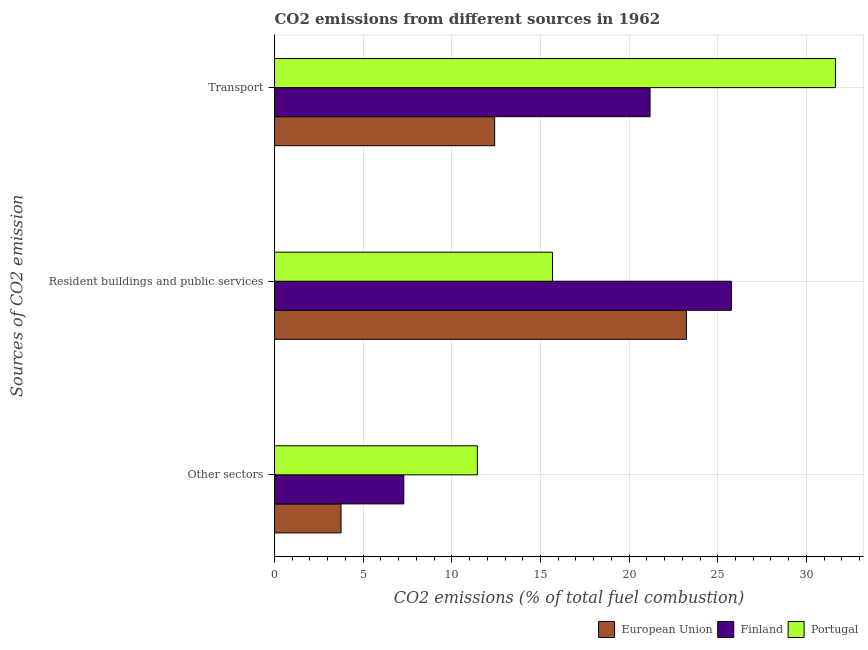Are the number of bars on each tick of the Y-axis equal?
Your response must be concise. Yes. How many bars are there on the 1st tick from the top?
Provide a short and direct response. 3. What is the label of the 3rd group of bars from the top?
Provide a short and direct response. Other sectors. What is the percentage of co2 emissions from other sectors in European Union?
Offer a terse response. 3.75. Across all countries, what is the maximum percentage of co2 emissions from resident buildings and public services?
Give a very brief answer. 25.77. Across all countries, what is the minimum percentage of co2 emissions from other sectors?
Your answer should be very brief. 3.75. In which country was the percentage of co2 emissions from transport maximum?
Your response must be concise. Portugal. In which country was the percentage of co2 emissions from other sectors minimum?
Give a very brief answer. European Union. What is the total percentage of co2 emissions from transport in the graph?
Provide a succinct answer. 65.24. What is the difference between the percentage of co2 emissions from other sectors in Portugal and that in Finland?
Your answer should be very brief. 4.15. What is the difference between the percentage of co2 emissions from resident buildings and public services in Portugal and the percentage of co2 emissions from transport in Finland?
Offer a terse response. -5.5. What is the average percentage of co2 emissions from other sectors per country?
Provide a short and direct response. 7.49. What is the difference between the percentage of co2 emissions from resident buildings and public services and percentage of co2 emissions from other sectors in Portugal?
Provide a short and direct response. 4.24. What is the ratio of the percentage of co2 emissions from transport in European Union to that in Portugal?
Your answer should be compact. 0.39. What is the difference between the highest and the second highest percentage of co2 emissions from transport?
Ensure brevity in your answer.  10.46. What is the difference between the highest and the lowest percentage of co2 emissions from transport?
Offer a terse response. 19.22. In how many countries, is the percentage of co2 emissions from resident buildings and public services greater than the average percentage of co2 emissions from resident buildings and public services taken over all countries?
Your response must be concise. 2. What does the 2nd bar from the bottom in Resident buildings and public services represents?
Ensure brevity in your answer.  Finland. How many bars are there?
Your answer should be very brief. 9. What is the difference between two consecutive major ticks on the X-axis?
Provide a succinct answer. 5. Are the values on the major ticks of X-axis written in scientific E-notation?
Offer a terse response. No. Does the graph contain grids?
Provide a short and direct response. Yes. How many legend labels are there?
Your answer should be compact. 3. How are the legend labels stacked?
Make the answer very short. Horizontal. What is the title of the graph?
Your answer should be compact. CO2 emissions from different sources in 1962. What is the label or title of the X-axis?
Your answer should be very brief. CO2 emissions (% of total fuel combustion). What is the label or title of the Y-axis?
Keep it short and to the point. Sources of CO2 emission. What is the CO2 emissions (% of total fuel combustion) in European Union in Other sectors?
Ensure brevity in your answer.  3.75. What is the CO2 emissions (% of total fuel combustion) of Finland in Other sectors?
Give a very brief answer. 7.29. What is the CO2 emissions (% of total fuel combustion) of Portugal in Other sectors?
Ensure brevity in your answer.  11.44. What is the CO2 emissions (% of total fuel combustion) in European Union in Resident buildings and public services?
Your response must be concise. 23.23. What is the CO2 emissions (% of total fuel combustion) in Finland in Resident buildings and public services?
Offer a terse response. 25.77. What is the CO2 emissions (% of total fuel combustion) in Portugal in Resident buildings and public services?
Provide a short and direct response. 15.68. What is the CO2 emissions (% of total fuel combustion) in European Union in Transport?
Keep it short and to the point. 12.42. What is the CO2 emissions (% of total fuel combustion) in Finland in Transport?
Your answer should be very brief. 21.18. What is the CO2 emissions (% of total fuel combustion) in Portugal in Transport?
Ensure brevity in your answer.  31.64. Across all Sources of CO2 emission, what is the maximum CO2 emissions (% of total fuel combustion) in European Union?
Give a very brief answer. 23.23. Across all Sources of CO2 emission, what is the maximum CO2 emissions (% of total fuel combustion) of Finland?
Provide a short and direct response. 25.77. Across all Sources of CO2 emission, what is the maximum CO2 emissions (% of total fuel combustion) in Portugal?
Offer a very short reply. 31.64. Across all Sources of CO2 emission, what is the minimum CO2 emissions (% of total fuel combustion) in European Union?
Provide a succinct answer. 3.75. Across all Sources of CO2 emission, what is the minimum CO2 emissions (% of total fuel combustion) in Finland?
Make the answer very short. 7.29. Across all Sources of CO2 emission, what is the minimum CO2 emissions (% of total fuel combustion) in Portugal?
Provide a succinct answer. 11.44. What is the total CO2 emissions (% of total fuel combustion) of European Union in the graph?
Keep it short and to the point. 39.4. What is the total CO2 emissions (% of total fuel combustion) in Finland in the graph?
Give a very brief answer. 54.24. What is the total CO2 emissions (% of total fuel combustion) in Portugal in the graph?
Provide a short and direct response. 58.76. What is the difference between the CO2 emissions (% of total fuel combustion) in European Union in Other sectors and that in Resident buildings and public services?
Make the answer very short. -19.48. What is the difference between the CO2 emissions (% of total fuel combustion) of Finland in Other sectors and that in Resident buildings and public services?
Your response must be concise. -18.48. What is the difference between the CO2 emissions (% of total fuel combustion) of Portugal in Other sectors and that in Resident buildings and public services?
Keep it short and to the point. -4.24. What is the difference between the CO2 emissions (% of total fuel combustion) of European Union in Other sectors and that in Transport?
Offer a terse response. -8.67. What is the difference between the CO2 emissions (% of total fuel combustion) of Finland in Other sectors and that in Transport?
Give a very brief answer. -13.89. What is the difference between the CO2 emissions (% of total fuel combustion) in Portugal in Other sectors and that in Transport?
Ensure brevity in your answer.  -20.2. What is the difference between the CO2 emissions (% of total fuel combustion) of European Union in Resident buildings and public services and that in Transport?
Your response must be concise. 10.81. What is the difference between the CO2 emissions (% of total fuel combustion) of Finland in Resident buildings and public services and that in Transport?
Your answer should be very brief. 4.59. What is the difference between the CO2 emissions (% of total fuel combustion) of Portugal in Resident buildings and public services and that in Transport?
Offer a terse response. -15.96. What is the difference between the CO2 emissions (% of total fuel combustion) in European Union in Other sectors and the CO2 emissions (% of total fuel combustion) in Finland in Resident buildings and public services?
Your answer should be very brief. -22.02. What is the difference between the CO2 emissions (% of total fuel combustion) in European Union in Other sectors and the CO2 emissions (% of total fuel combustion) in Portugal in Resident buildings and public services?
Offer a terse response. -11.93. What is the difference between the CO2 emissions (% of total fuel combustion) in Finland in Other sectors and the CO2 emissions (% of total fuel combustion) in Portugal in Resident buildings and public services?
Ensure brevity in your answer.  -8.39. What is the difference between the CO2 emissions (% of total fuel combustion) of European Union in Other sectors and the CO2 emissions (% of total fuel combustion) of Finland in Transport?
Provide a short and direct response. -17.43. What is the difference between the CO2 emissions (% of total fuel combustion) in European Union in Other sectors and the CO2 emissions (% of total fuel combustion) in Portugal in Transport?
Give a very brief answer. -27.89. What is the difference between the CO2 emissions (% of total fuel combustion) of Finland in Other sectors and the CO2 emissions (% of total fuel combustion) of Portugal in Transport?
Ensure brevity in your answer.  -24.35. What is the difference between the CO2 emissions (% of total fuel combustion) of European Union in Resident buildings and public services and the CO2 emissions (% of total fuel combustion) of Finland in Transport?
Provide a succinct answer. 2.05. What is the difference between the CO2 emissions (% of total fuel combustion) of European Union in Resident buildings and public services and the CO2 emissions (% of total fuel combustion) of Portugal in Transport?
Give a very brief answer. -8.41. What is the difference between the CO2 emissions (% of total fuel combustion) in Finland in Resident buildings and public services and the CO2 emissions (% of total fuel combustion) in Portugal in Transport?
Offer a very short reply. -5.87. What is the average CO2 emissions (% of total fuel combustion) in European Union per Sources of CO2 emission?
Give a very brief answer. 13.13. What is the average CO2 emissions (% of total fuel combustion) in Finland per Sources of CO2 emission?
Keep it short and to the point. 18.08. What is the average CO2 emissions (% of total fuel combustion) of Portugal per Sources of CO2 emission?
Provide a succinct answer. 19.59. What is the difference between the CO2 emissions (% of total fuel combustion) of European Union and CO2 emissions (% of total fuel combustion) of Finland in Other sectors?
Provide a succinct answer. -3.54. What is the difference between the CO2 emissions (% of total fuel combustion) of European Union and CO2 emissions (% of total fuel combustion) of Portugal in Other sectors?
Your answer should be compact. -7.69. What is the difference between the CO2 emissions (% of total fuel combustion) in Finland and CO2 emissions (% of total fuel combustion) in Portugal in Other sectors?
Your response must be concise. -4.15. What is the difference between the CO2 emissions (% of total fuel combustion) of European Union and CO2 emissions (% of total fuel combustion) of Finland in Resident buildings and public services?
Offer a very short reply. -2.54. What is the difference between the CO2 emissions (% of total fuel combustion) in European Union and CO2 emissions (% of total fuel combustion) in Portugal in Resident buildings and public services?
Offer a terse response. 7.55. What is the difference between the CO2 emissions (% of total fuel combustion) in Finland and CO2 emissions (% of total fuel combustion) in Portugal in Resident buildings and public services?
Offer a terse response. 10.09. What is the difference between the CO2 emissions (% of total fuel combustion) of European Union and CO2 emissions (% of total fuel combustion) of Finland in Transport?
Provide a short and direct response. -8.76. What is the difference between the CO2 emissions (% of total fuel combustion) of European Union and CO2 emissions (% of total fuel combustion) of Portugal in Transport?
Your answer should be compact. -19.22. What is the difference between the CO2 emissions (% of total fuel combustion) in Finland and CO2 emissions (% of total fuel combustion) in Portugal in Transport?
Provide a short and direct response. -10.46. What is the ratio of the CO2 emissions (% of total fuel combustion) of European Union in Other sectors to that in Resident buildings and public services?
Offer a very short reply. 0.16. What is the ratio of the CO2 emissions (% of total fuel combustion) in Finland in Other sectors to that in Resident buildings and public services?
Make the answer very short. 0.28. What is the ratio of the CO2 emissions (% of total fuel combustion) of Portugal in Other sectors to that in Resident buildings and public services?
Offer a terse response. 0.73. What is the ratio of the CO2 emissions (% of total fuel combustion) of European Union in Other sectors to that in Transport?
Your answer should be very brief. 0.3. What is the ratio of the CO2 emissions (% of total fuel combustion) of Finland in Other sectors to that in Transport?
Provide a short and direct response. 0.34. What is the ratio of the CO2 emissions (% of total fuel combustion) of Portugal in Other sectors to that in Transport?
Your answer should be compact. 0.36. What is the ratio of the CO2 emissions (% of total fuel combustion) of European Union in Resident buildings and public services to that in Transport?
Keep it short and to the point. 1.87. What is the ratio of the CO2 emissions (% of total fuel combustion) in Finland in Resident buildings and public services to that in Transport?
Keep it short and to the point. 1.22. What is the ratio of the CO2 emissions (% of total fuel combustion) of Portugal in Resident buildings and public services to that in Transport?
Your response must be concise. 0.5. What is the difference between the highest and the second highest CO2 emissions (% of total fuel combustion) in European Union?
Give a very brief answer. 10.81. What is the difference between the highest and the second highest CO2 emissions (% of total fuel combustion) of Finland?
Your response must be concise. 4.59. What is the difference between the highest and the second highest CO2 emissions (% of total fuel combustion) of Portugal?
Offer a very short reply. 15.96. What is the difference between the highest and the lowest CO2 emissions (% of total fuel combustion) in European Union?
Make the answer very short. 19.48. What is the difference between the highest and the lowest CO2 emissions (% of total fuel combustion) in Finland?
Give a very brief answer. 18.48. What is the difference between the highest and the lowest CO2 emissions (% of total fuel combustion) of Portugal?
Your response must be concise. 20.2. 